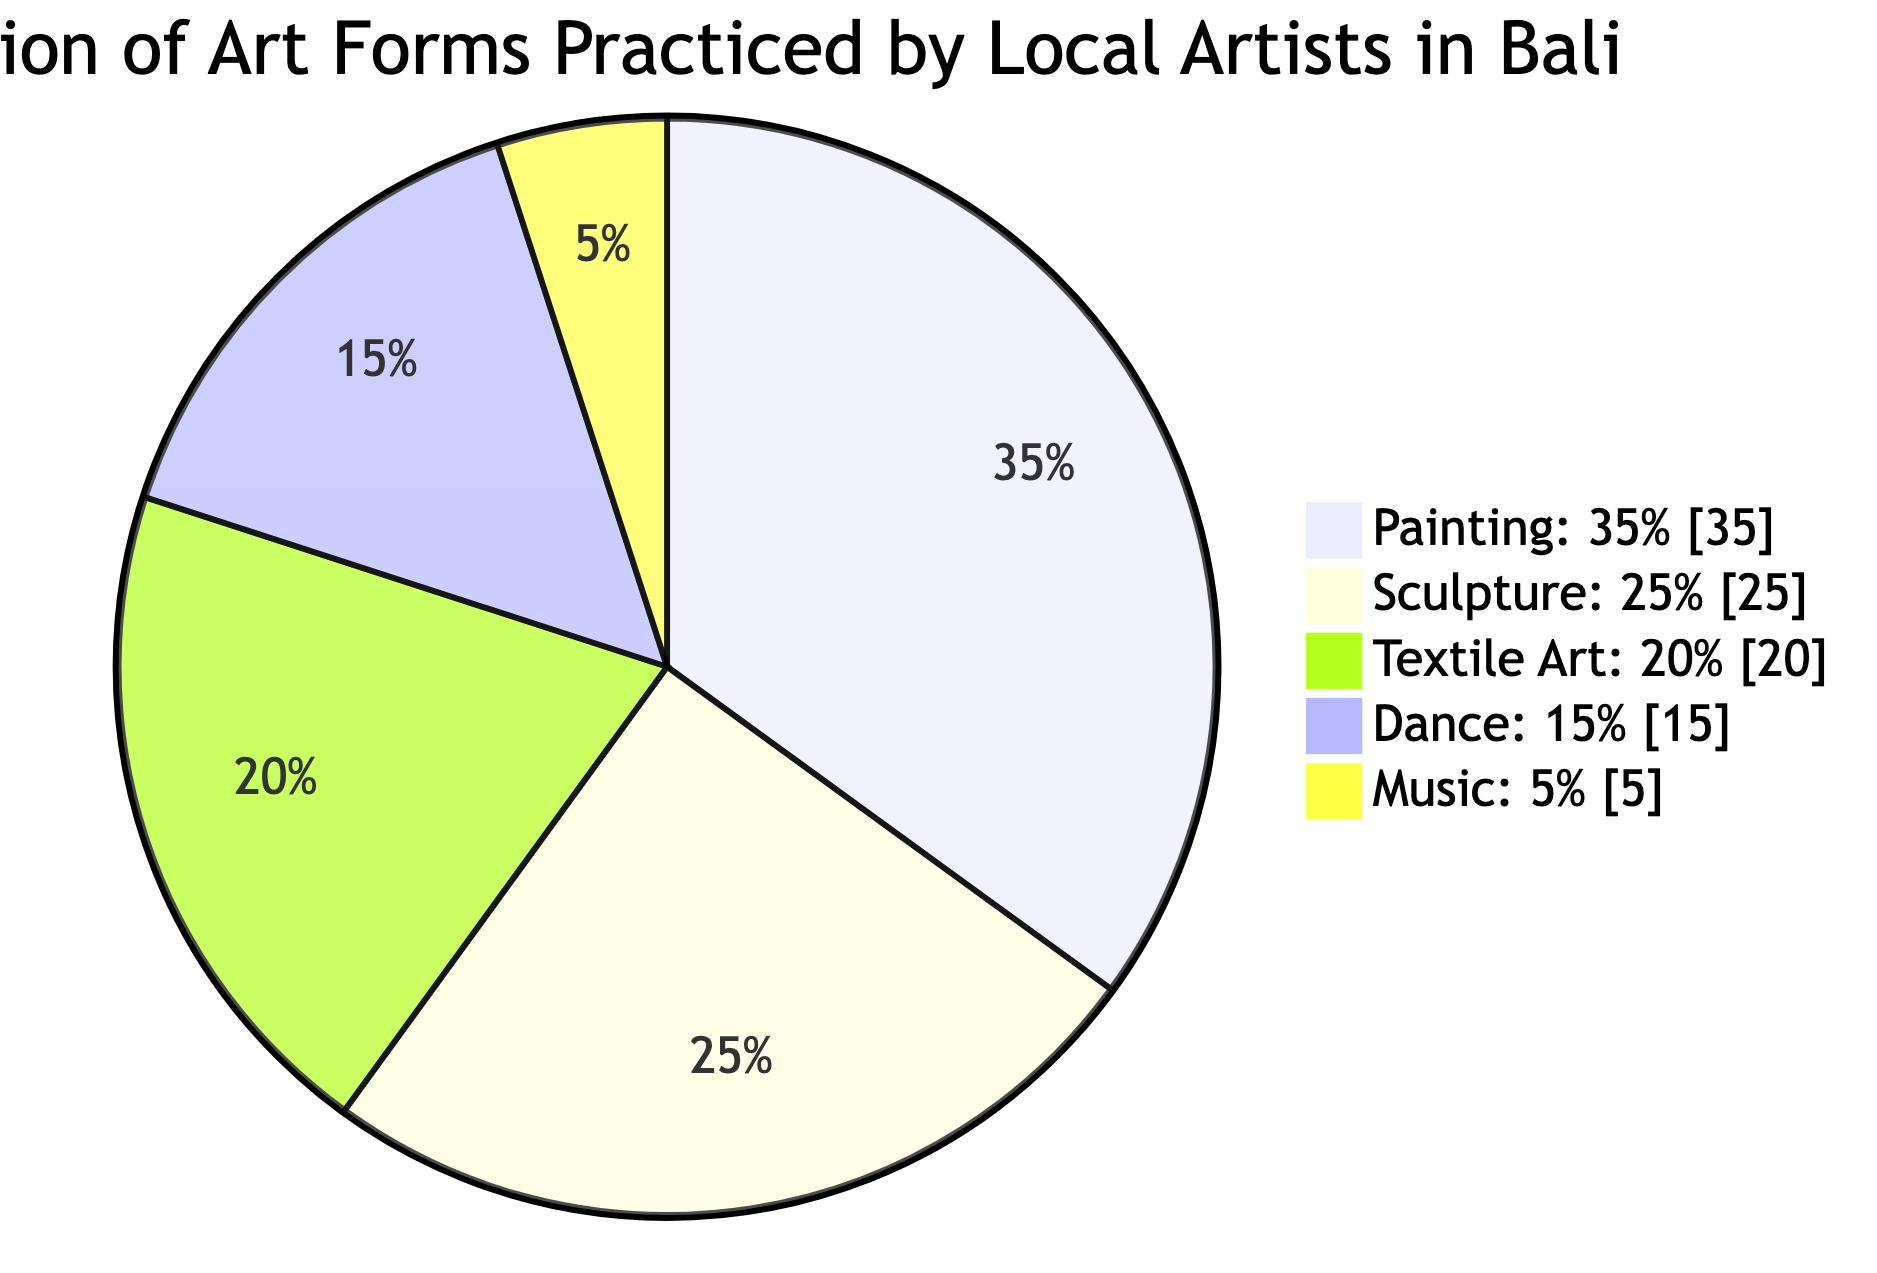What percentage of local artists practice painting? The diagram states that painting constitutes 35% of the art forms practiced by local artists in Bali. This information is clearly labeled next to the painting segment of the pie chart.
Answer: 35% Which art form has the highest representation? By analyzing the segments, painting is the largest slice at 35%, making it the most practiced art form among local artists.
Answer: Painting What is the total percentage of dance and music art forms? Adding the percentages for dance (15%) and music (5%) results in a total of 20%. This requires simple addition of the segments corresponding to these two art forms.
Answer: 20% How many art forms are represented in the diagram? There are five distinct segments in the pie chart, representing five different art forms practiced by local artists.
Answer: 5 What percentage of artists practice either sculpture or textile art? The percentage for sculpture is 25% and textile art is 20%. Adding these together gives a total of 45%, which reflects the combined representation of these two forms.
Answer: 45% What is the least practiced art form according to the chart? By examining the segments, music, which accounts for only 5% of the total, is the smallest slice, indicating it is the least practiced art form.
Answer: Music Which two art forms combined represent more than half of local artists' practices? Adding the percentages of painting (35%) and sculpture (25%) yields a total of 60%. This total clearly exceeds 50%, indicating that these two forms together dominate the practices.
Answer: Painting and Sculpture What is the difference in percentage between textile art and dance? The textile art is 20% and dance is 15%. The difference of 5% shows that textile art is practiced by a larger portion of artists compared to dance.
Answer: 5% What fraction of the total does music represent? Since music accounts for 5% of the total, it represents 1/20 of the overall distribution. This requires understanding that 5% is equivalent to one out of twenty equal parts of 100%.
Answer: 1/20 